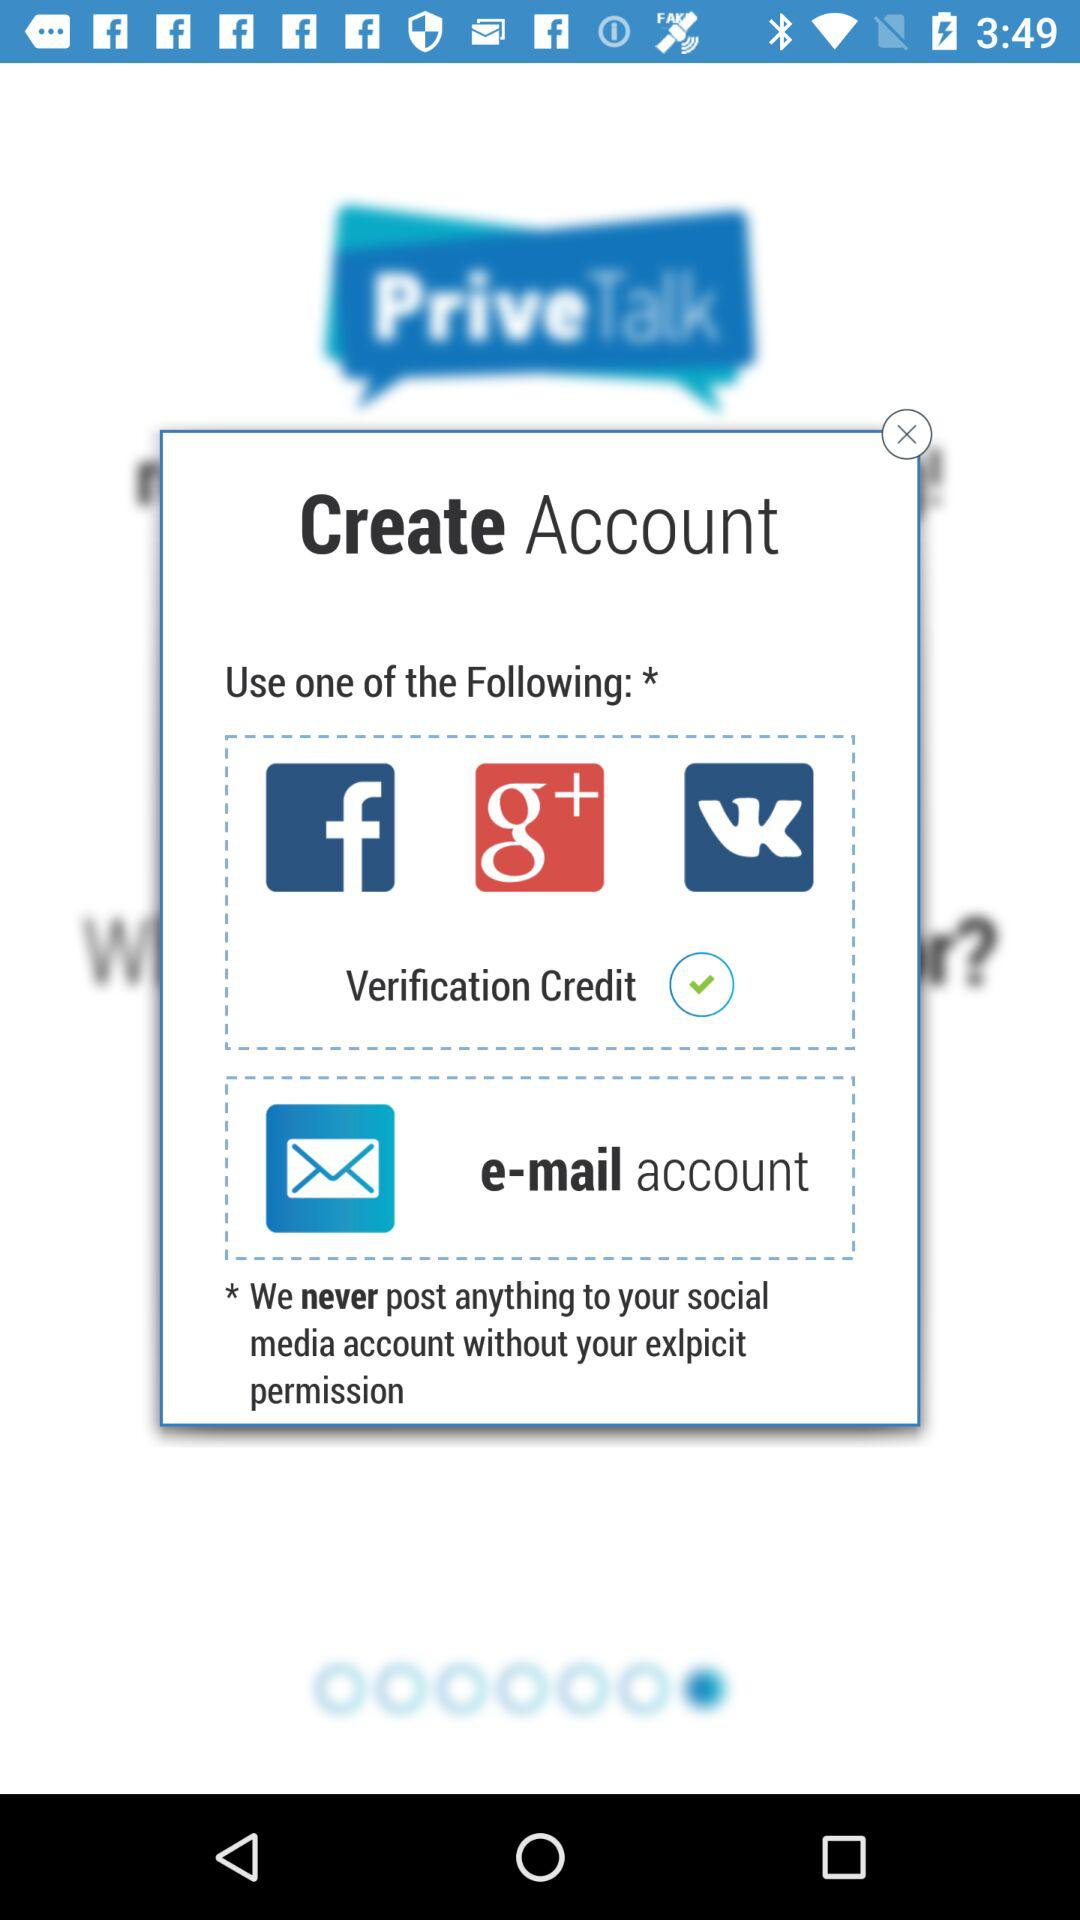What's the status of the verification credit? The status is on. 